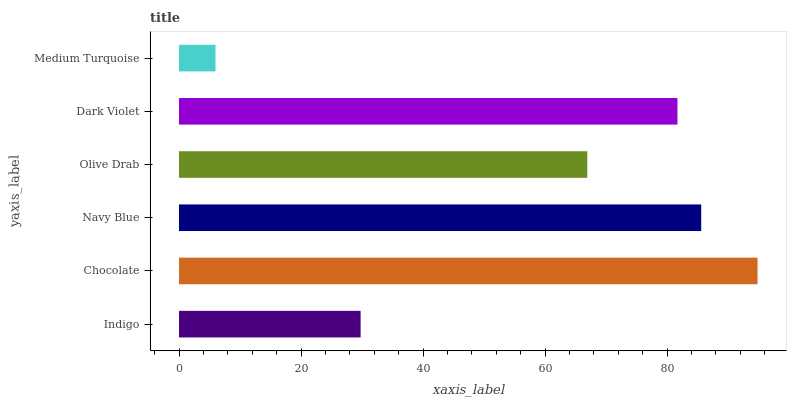Is Medium Turquoise the minimum?
Answer yes or no. Yes. Is Chocolate the maximum?
Answer yes or no. Yes. Is Navy Blue the minimum?
Answer yes or no. No. Is Navy Blue the maximum?
Answer yes or no. No. Is Chocolate greater than Navy Blue?
Answer yes or no. Yes. Is Navy Blue less than Chocolate?
Answer yes or no. Yes. Is Navy Blue greater than Chocolate?
Answer yes or no. No. Is Chocolate less than Navy Blue?
Answer yes or no. No. Is Dark Violet the high median?
Answer yes or no. Yes. Is Olive Drab the low median?
Answer yes or no. Yes. Is Chocolate the high median?
Answer yes or no. No. Is Navy Blue the low median?
Answer yes or no. No. 